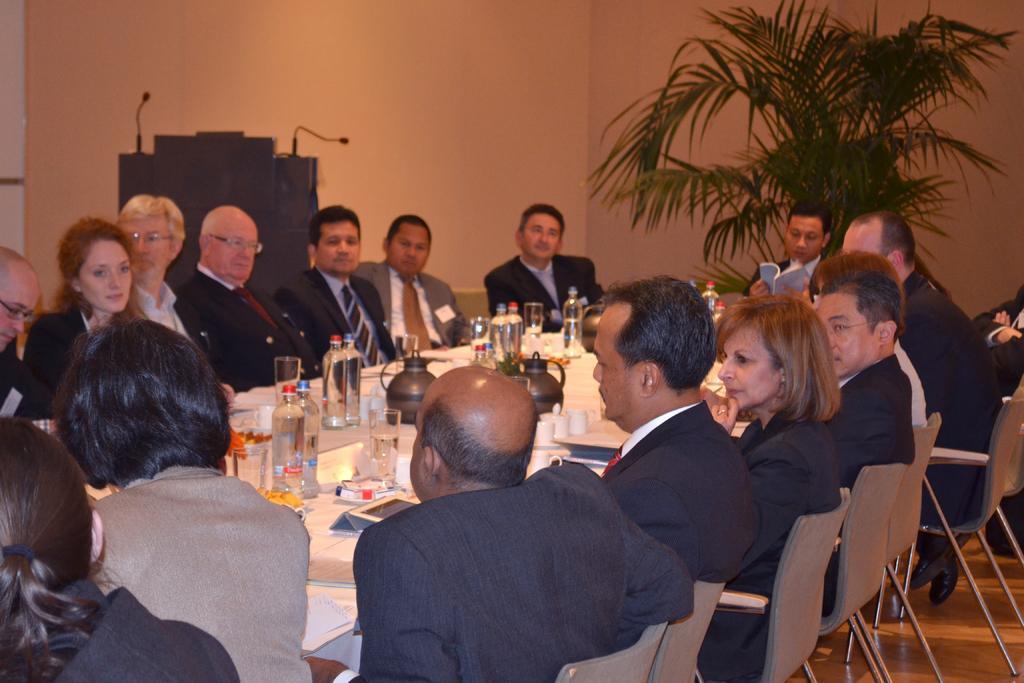Could you give a brief overview of what you see in this image? A group of people sitting on the chair surrounding the table, On the table there are some bottles and glasses. Top right side of the image there is a plant. In the middle of the image there is a wall. 